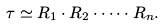<formula> <loc_0><loc_0><loc_500><loc_500>\tau \simeq R _ { 1 } \cdot R _ { 2 } \cdot \dots \cdot R _ { n } .</formula> 